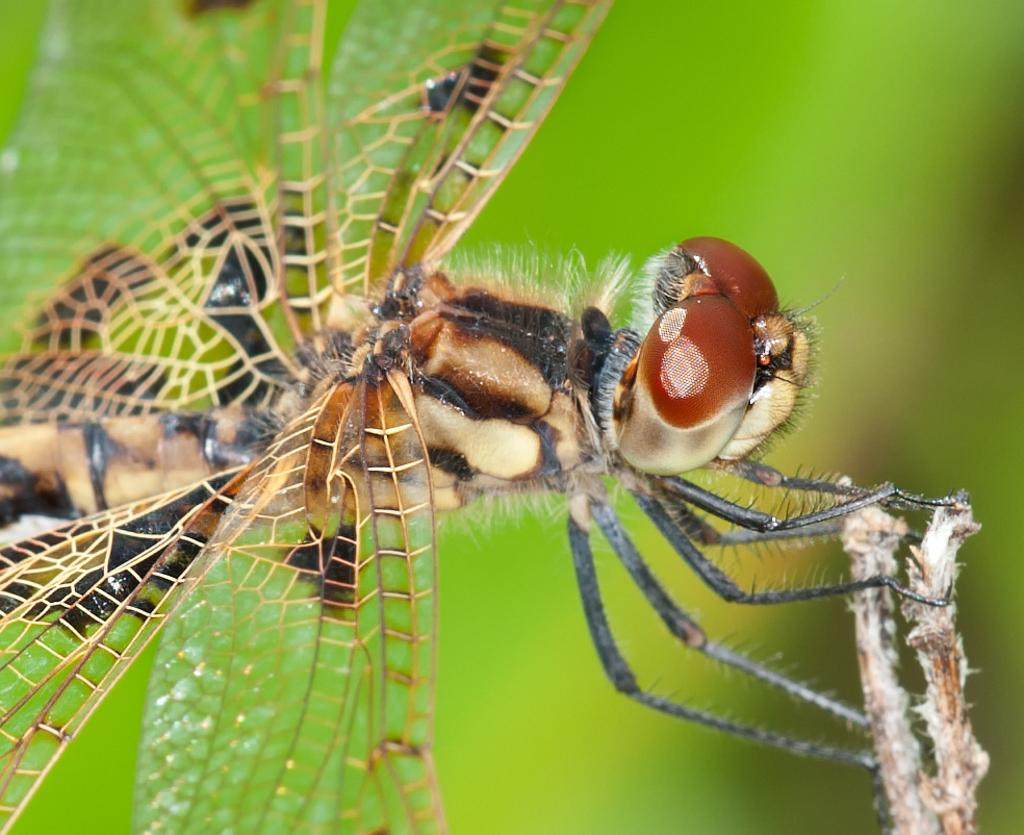What type of creature is present in the image? There is an insect in the image. What colors can be seen on the insect? The insect has black and brown colors. What is the color of the background in the image? The background of the image is green. What type of car can be seen in the image? There is no car present in the image; it features an insect with black and brown colors against a green background. What is the insect using to hammer in the image? There is no hammer or any indication of hammering in the image. 